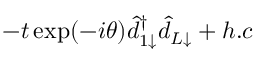<formula> <loc_0><loc_0><loc_500><loc_500>- t \exp ( - i \theta ) \hat { d } _ { 1 \downarrow } ^ { \dagger } \hat { d } _ { L \downarrow } + h . c</formula> 